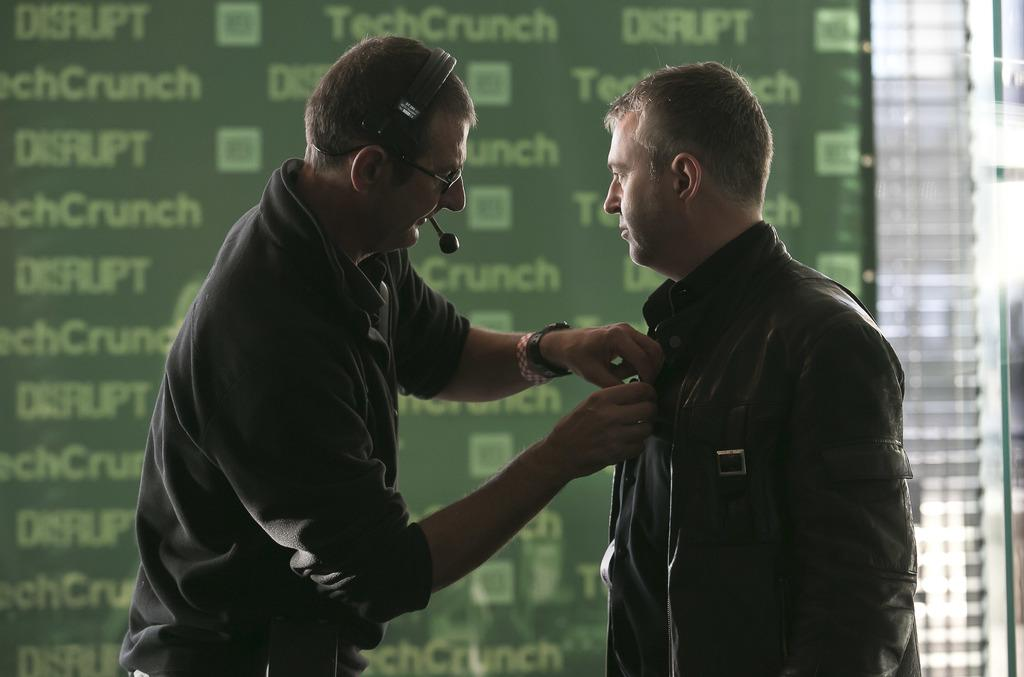How many people are in the image? There are persons in the image, but the exact number is not specified. What are the people wearing in the image? The persons in the image are wearing clothes. What additional feature can be seen in the image? There is a sponsor board in the image. What type of regret is expressed by the persons in the image? There is no indication of regret in the image; the people are simply present and wearing clothes. How does the image compare to other similar images? The image cannot be compared to other similar images since no other images are mentioned or available for comparison. 